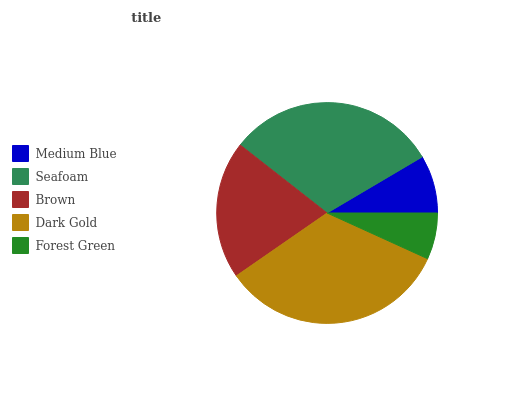Is Forest Green the minimum?
Answer yes or no. Yes. Is Dark Gold the maximum?
Answer yes or no. Yes. Is Seafoam the minimum?
Answer yes or no. No. Is Seafoam the maximum?
Answer yes or no. No. Is Seafoam greater than Medium Blue?
Answer yes or no. Yes. Is Medium Blue less than Seafoam?
Answer yes or no. Yes. Is Medium Blue greater than Seafoam?
Answer yes or no. No. Is Seafoam less than Medium Blue?
Answer yes or no. No. Is Brown the high median?
Answer yes or no. Yes. Is Brown the low median?
Answer yes or no. Yes. Is Dark Gold the high median?
Answer yes or no. No. Is Medium Blue the low median?
Answer yes or no. No. 